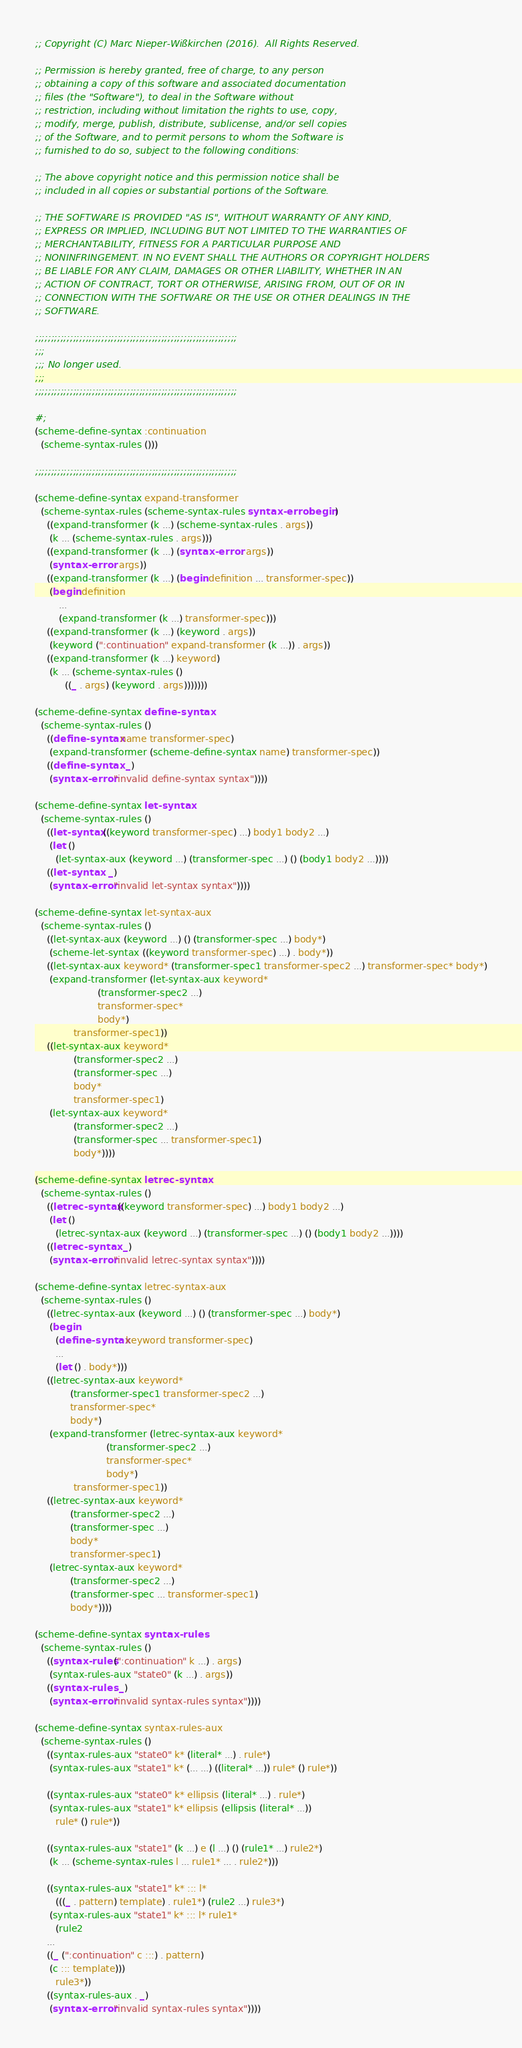<code> <loc_0><loc_0><loc_500><loc_500><_Scheme_>;; Copyright (C) Marc Nieper-Wißkirchen (2016).  All Rights Reserved. 

;; Permission is hereby granted, free of charge, to any person
;; obtaining a copy of this software and associated documentation
;; files (the "Software"), to deal in the Software without
;; restriction, including without limitation the rights to use, copy,
;; modify, merge, publish, distribute, sublicense, and/or sell copies
;; of the Software, and to permit persons to whom the Software is
;; furnished to do so, subject to the following conditions:

;; The above copyright notice and this permission notice shall be
;; included in all copies or substantial portions of the Software.

;; THE SOFTWARE IS PROVIDED "AS IS", WITHOUT WARRANTY OF ANY KIND,
;; EXPRESS OR IMPLIED, INCLUDING BUT NOT LIMITED TO THE WARRANTIES OF
;; MERCHANTABILITY, FITNESS FOR A PARTICULAR PURPOSE AND
;; NONINFRINGEMENT. IN NO EVENT SHALL THE AUTHORS OR COPYRIGHT HOLDERS
;; BE LIABLE FOR ANY CLAIM, DAMAGES OR OTHER LIABILITY, WHETHER IN AN
;; ACTION OF CONTRACT, TORT OR OTHERWISE, ARISING FROM, OUT OF OR IN
;; CONNECTION WITH THE SOFTWARE OR THE USE OR OTHER DEALINGS IN THE
;; SOFTWARE.

;;;;;;;;;;;;;;;;;;;;;;;;;;;;;;;;;;;;;;;;;;;;;;;;;;;;;;;;;;;;;;;;
;;;
;;; No longer used.
;;;
;;;;;;;;;;;;;;;;;;;;;;;;;;;;;;;;;;;;;;;;;;;;;;;;;;;;;;;;;;;;;;;;

#;
(scheme-define-syntax :continuation
  (scheme-syntax-rules ()))

;;;;;;;;;;;;;;;;;;;;;;;;;;;;;;;;;;;;;;;;;;;;;;;;;;;;;;;;;;;;;;;;

(scheme-define-syntax expand-transformer
  (scheme-syntax-rules (scheme-syntax-rules syntax-error begin)
    ((expand-transformer (k ...) (scheme-syntax-rules . args))
     (k ... (scheme-syntax-rules . args)))
    ((expand-transformer (k ...) (syntax-error . args))
     (syntax-error . args))
    ((expand-transformer (k ...) (begin definition ... transformer-spec))
     (begin definition
	    ...
	    (expand-transformer (k ...) transformer-spec)))   
    ((expand-transformer (k ...) (keyword . args))
     (keyword (":continuation" expand-transformer (k ...)) . args))
    ((expand-transformer (k ...) keyword)
     (k ... (scheme-syntax-rules ()
	      ((_ . args) (keyword . args)))))))

(scheme-define-syntax define-syntax
  (scheme-syntax-rules ()
    ((define-syntax name transformer-spec)
     (expand-transformer (scheme-define-syntax name) transformer-spec))
    ((define-syntax . _)
     (syntax-error "invalid define-syntax syntax"))))

(scheme-define-syntax let-syntax
  (scheme-syntax-rules ()
    ((let-syntax ((keyword transformer-spec) ...) body1 body2 ...)
     (let ()
       (let-syntax-aux (keyword ...) (transformer-spec ...) () (body1 body2 ...))))
    ((let-syntax . _)
     (syntax-error "invalid let-syntax syntax"))))

(scheme-define-syntax let-syntax-aux
  (scheme-syntax-rules ()
    ((let-syntax-aux (keyword ...) () (transformer-spec ...) body*)
     (scheme-let-syntax ((keyword transformer-spec) ...) . body*))
    ((let-syntax-aux keyword* (transformer-spec1 transformer-spec2 ...) transformer-spec* body*)
     (expand-transformer (let-syntax-aux keyword*
					 (transformer-spec2 ...)
					 transformer-spec*
					 body*)
			 transformer-spec1))
    ((let-syntax-aux keyword*
		     (transformer-spec2 ...)
		     (transformer-spec ...)
		     body*
		     transformer-spec1)
     (let-syntax-aux keyword*
		     (transformer-spec2 ...)
		     (transformer-spec ... transformer-spec1)
		     body*))))

(scheme-define-syntax letrec-syntax
  (scheme-syntax-rules ()
    ((letrec-syntax ((keyword transformer-spec) ...) body1 body2 ...)
     (let ()
       (letrec-syntax-aux (keyword ...) (transformer-spec ...) () (body1 body2 ...))))
    ((letrec-syntax . _)
     (syntax-error "invalid letrec-syntax syntax"))))

(scheme-define-syntax letrec-syntax-aux
  (scheme-syntax-rules ()
    ((letrec-syntax-aux (keyword ...) () (transformer-spec ...) body*)
     (begin
       (define-syntax keyword transformer-spec)
       ...
       (let () . body*)))
    ((letrec-syntax-aux keyword*
			(transformer-spec1 transformer-spec2 ...)
			transformer-spec*
			body*)
     (expand-transformer (letrec-syntax-aux keyword*
					    (transformer-spec2 ...)
					    transformer-spec*
					    body*)
			 transformer-spec1))
    ((letrec-syntax-aux keyword*
			(transformer-spec2 ...)
			(transformer-spec ...)
			body*
			transformer-spec1)
     (letrec-syntax-aux keyword*
			(transformer-spec2 ...)
			(transformer-spec ... transformer-spec1)
			body*))))

(scheme-define-syntax syntax-rules
  (scheme-syntax-rules ()
    ((syntax-rules (":continuation" k ...) . args)
     (syntax-rules-aux "state0" (k ...) . args))
    ((syntax-rules . _)
     (syntax-error "invalid syntax-rules syntax"))))

(scheme-define-syntax syntax-rules-aux
  (scheme-syntax-rules ()
    ((syntax-rules-aux "state0" k* (literal* ...) . rule*)
     (syntax-rules-aux "state1" k* (... ...) ((literal* ...)) rule* () rule*))

    ((syntax-rules-aux "state0" k* ellipsis (literal* ...) . rule*)
     (syntax-rules-aux "state1" k* ellipsis (ellipsis (literal* ...))
       rule* () rule*))
   
    ((syntax-rules-aux "state1" (k ...) e (l ...) () (rule1* ...) rule2*)
     (k ... (scheme-syntax-rules l ... rule1* ... . rule2*)))

    ((syntax-rules-aux "state1" k* ::: l*
       (((_ . pattern) template) . rule1*) (rule2 ...) rule3*)
     (syntax-rules-aux "state1" k* ::: l* rule1*
       (rule2
	...
	((_ (":continuation" c :::) . pattern)
	 (c ::: template)))
       rule3*))
    ((syntax-rules-aux . _)
     (syntax-error "invalid syntax-rules syntax"))))
</code> 